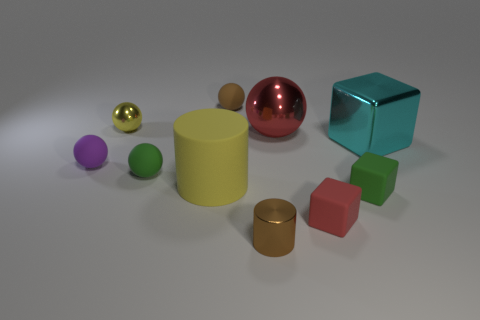Subtract 2 balls. How many balls are left? 3 Subtract all yellow spheres. How many spheres are left? 4 Subtract all small metallic balls. How many balls are left? 4 Subtract all blue balls. Subtract all yellow cubes. How many balls are left? 5 Subtract all cylinders. How many objects are left? 8 Add 2 yellow matte cylinders. How many yellow matte cylinders are left? 3 Add 3 small brown rubber things. How many small brown rubber things exist? 4 Subtract 0 cyan balls. How many objects are left? 10 Subtract all tiny purple cubes. Subtract all tiny purple matte balls. How many objects are left? 9 